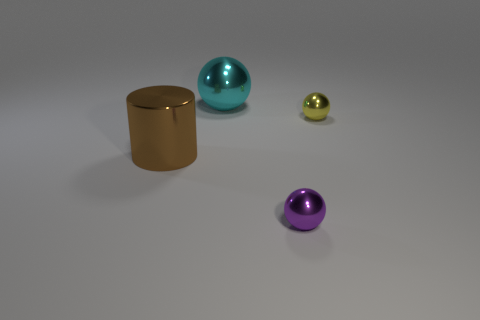Add 4 big brown objects. How many objects exist? 8 Subtract all cylinders. How many objects are left? 3 Subtract all small yellow metal objects. Subtract all big shiny spheres. How many objects are left? 2 Add 4 tiny yellow shiny objects. How many tiny yellow shiny objects are left? 5 Add 2 large things. How many large things exist? 4 Subtract 0 gray cubes. How many objects are left? 4 